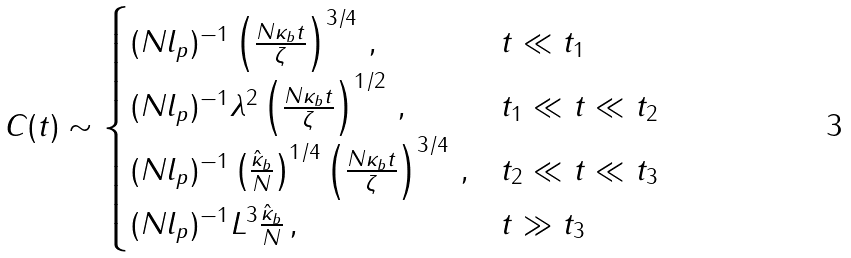<formula> <loc_0><loc_0><loc_500><loc_500>C ( t ) \sim \begin{cases} ( N l _ { p } ) ^ { - 1 } \left ( \frac { N \kappa _ { b } t } { \zeta } \right ) ^ { 3 / 4 } \, , & \text {$t \ll    t_{1}$} \\ ( N l _ { p } ) ^ { - 1 } \lambda ^ { 2 } \left ( \frac { N \kappa _ { b } t } { \zeta } \right ) ^ { 1 / 2 } \, , & t _ { 1 } \ll t \ll t _ { 2 } \\ ( N l _ { p } ) ^ { - 1 } \left ( \frac { \hat { \kappa } _ { b } } { N } \right ) ^ { 1 / 4 } \left ( \frac { N \kappa _ { b } t } { \zeta } \right ) ^ { 3 / 4 } \, , & \text {$ t_{2} \ll t \ll    t_{3}$} \\ ( N l _ { p } ) ^ { - 1 } L ^ { 3 } \frac { \hat { \kappa } _ { b } } { N } \, , & \text {$t \gg t_{3}$} \end{cases}</formula> 